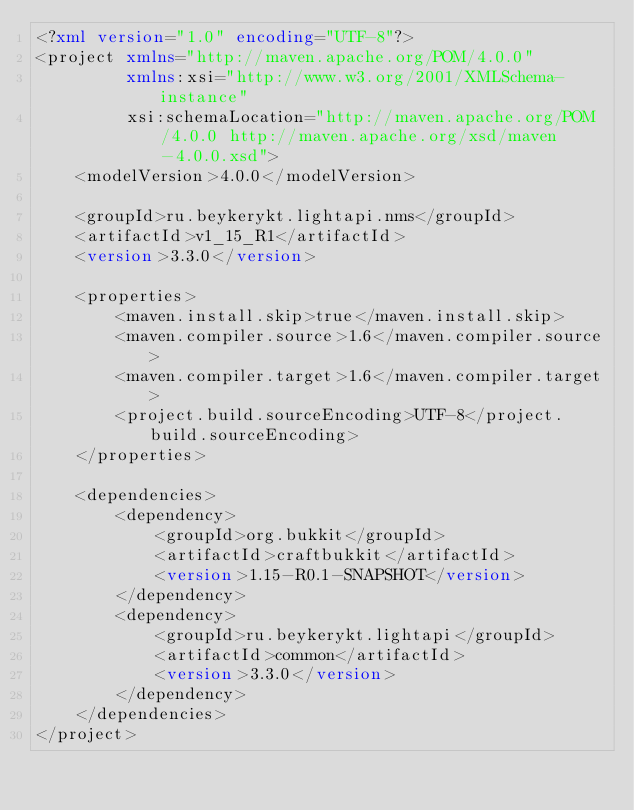<code> <loc_0><loc_0><loc_500><loc_500><_XML_><?xml version="1.0" encoding="UTF-8"?>
<project xmlns="http://maven.apache.org/POM/4.0.0"
         xmlns:xsi="http://www.w3.org/2001/XMLSchema-instance"
         xsi:schemaLocation="http://maven.apache.org/POM/4.0.0 http://maven.apache.org/xsd/maven-4.0.0.xsd">
    <modelVersion>4.0.0</modelVersion>

    <groupId>ru.beykerykt.lightapi.nms</groupId>
    <artifactId>v1_15_R1</artifactId>
    <version>3.3.0</version>

    <properties>
        <maven.install.skip>true</maven.install.skip>
        <maven.compiler.source>1.6</maven.compiler.source>
        <maven.compiler.target>1.6</maven.compiler.target>
        <project.build.sourceEncoding>UTF-8</project.build.sourceEncoding>
    </properties>

    <dependencies>
        <dependency>
            <groupId>org.bukkit</groupId>
            <artifactId>craftbukkit</artifactId>
            <version>1.15-R0.1-SNAPSHOT</version>
        </dependency>
        <dependency>
            <groupId>ru.beykerykt.lightapi</groupId>
            <artifactId>common</artifactId>
            <version>3.3.0</version>
        </dependency>
    </dependencies>
</project></code> 